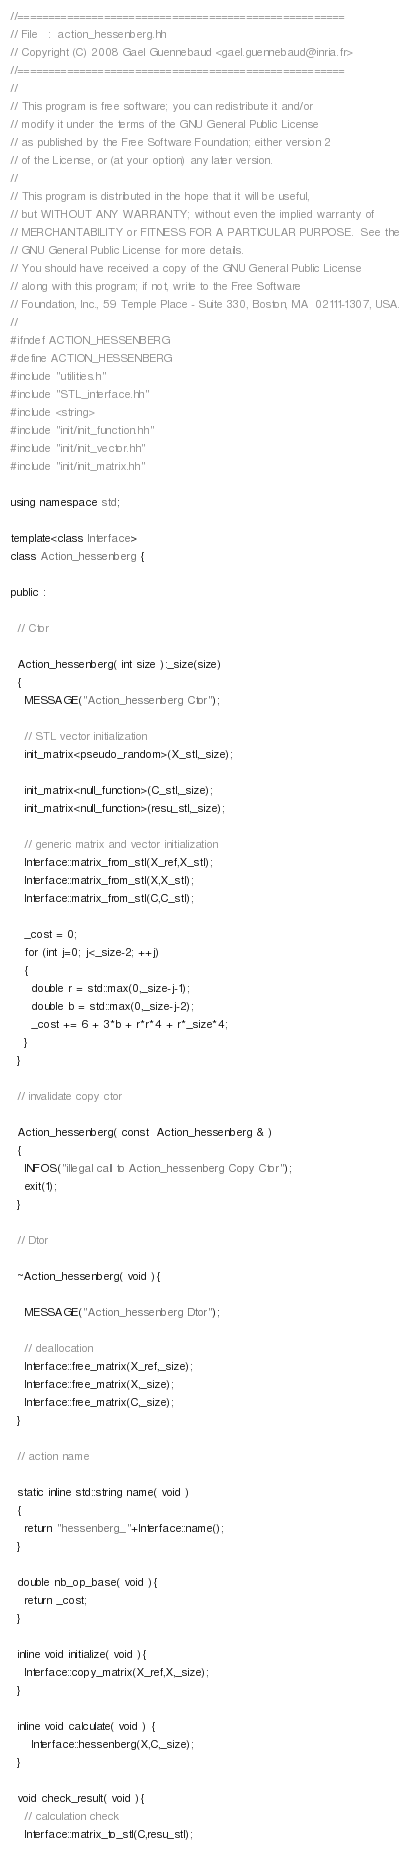<code> <loc_0><loc_0><loc_500><loc_500><_C++_>//=====================================================
// File   :  action_hessenberg.hh
// Copyright (C) 2008 Gael Guennebaud <gael.guennebaud@inria.fr>
//=====================================================
//
// This program is free software; you can redistribute it and/or
// modify it under the terms of the GNU General Public License
// as published by the Free Software Foundation; either version 2
// of the License, or (at your option) any later version.
//
// This program is distributed in the hope that it will be useful,
// but WITHOUT ANY WARRANTY; without even the implied warranty of
// MERCHANTABILITY or FITNESS FOR A PARTICULAR PURPOSE.  See the
// GNU General Public License for more details.
// You should have received a copy of the GNU General Public License
// along with this program; if not, write to the Free Software
// Foundation, Inc., 59 Temple Place - Suite 330, Boston, MA  02111-1307, USA.
//
#ifndef ACTION_HESSENBERG
#define ACTION_HESSENBERG
#include "utilities.h"
#include "STL_interface.hh"
#include <string>
#include "init/init_function.hh"
#include "init/init_vector.hh"
#include "init/init_matrix.hh"

using namespace std;

template<class Interface>
class Action_hessenberg {

public :

  // Ctor

  Action_hessenberg( int size ):_size(size)
  {
    MESSAGE("Action_hessenberg Ctor");

    // STL vector initialization
    init_matrix<pseudo_random>(X_stl,_size);

    init_matrix<null_function>(C_stl,_size);
    init_matrix<null_function>(resu_stl,_size);

    // generic matrix and vector initialization
    Interface::matrix_from_stl(X_ref,X_stl);
    Interface::matrix_from_stl(X,X_stl);
    Interface::matrix_from_stl(C,C_stl);

    _cost = 0;
    for (int j=0; j<_size-2; ++j)
    {
      double r = std::max(0,_size-j-1);
      double b = std::max(0,_size-j-2);
      _cost += 6 + 3*b + r*r*4 + r*_size*4;
    }
  }

  // invalidate copy ctor

  Action_hessenberg( const  Action_hessenberg & )
  {
    INFOS("illegal call to Action_hessenberg Copy Ctor");
    exit(1);
  }

  // Dtor

  ~Action_hessenberg( void ){

    MESSAGE("Action_hessenberg Dtor");

    // deallocation
    Interface::free_matrix(X_ref,_size);
    Interface::free_matrix(X,_size);
    Interface::free_matrix(C,_size);
  }

  // action name

  static inline std::string name( void )
  {
    return "hessenberg_"+Interface::name();
  }

  double nb_op_base( void ){
    return _cost;
  }

  inline void initialize( void ){
    Interface::copy_matrix(X_ref,X,_size);
  }

  inline void calculate( void ) {
      Interface::hessenberg(X,C,_size);
  }

  void check_result( void ){
    // calculation check
    Interface::matrix_to_stl(C,resu_stl);
</code> 